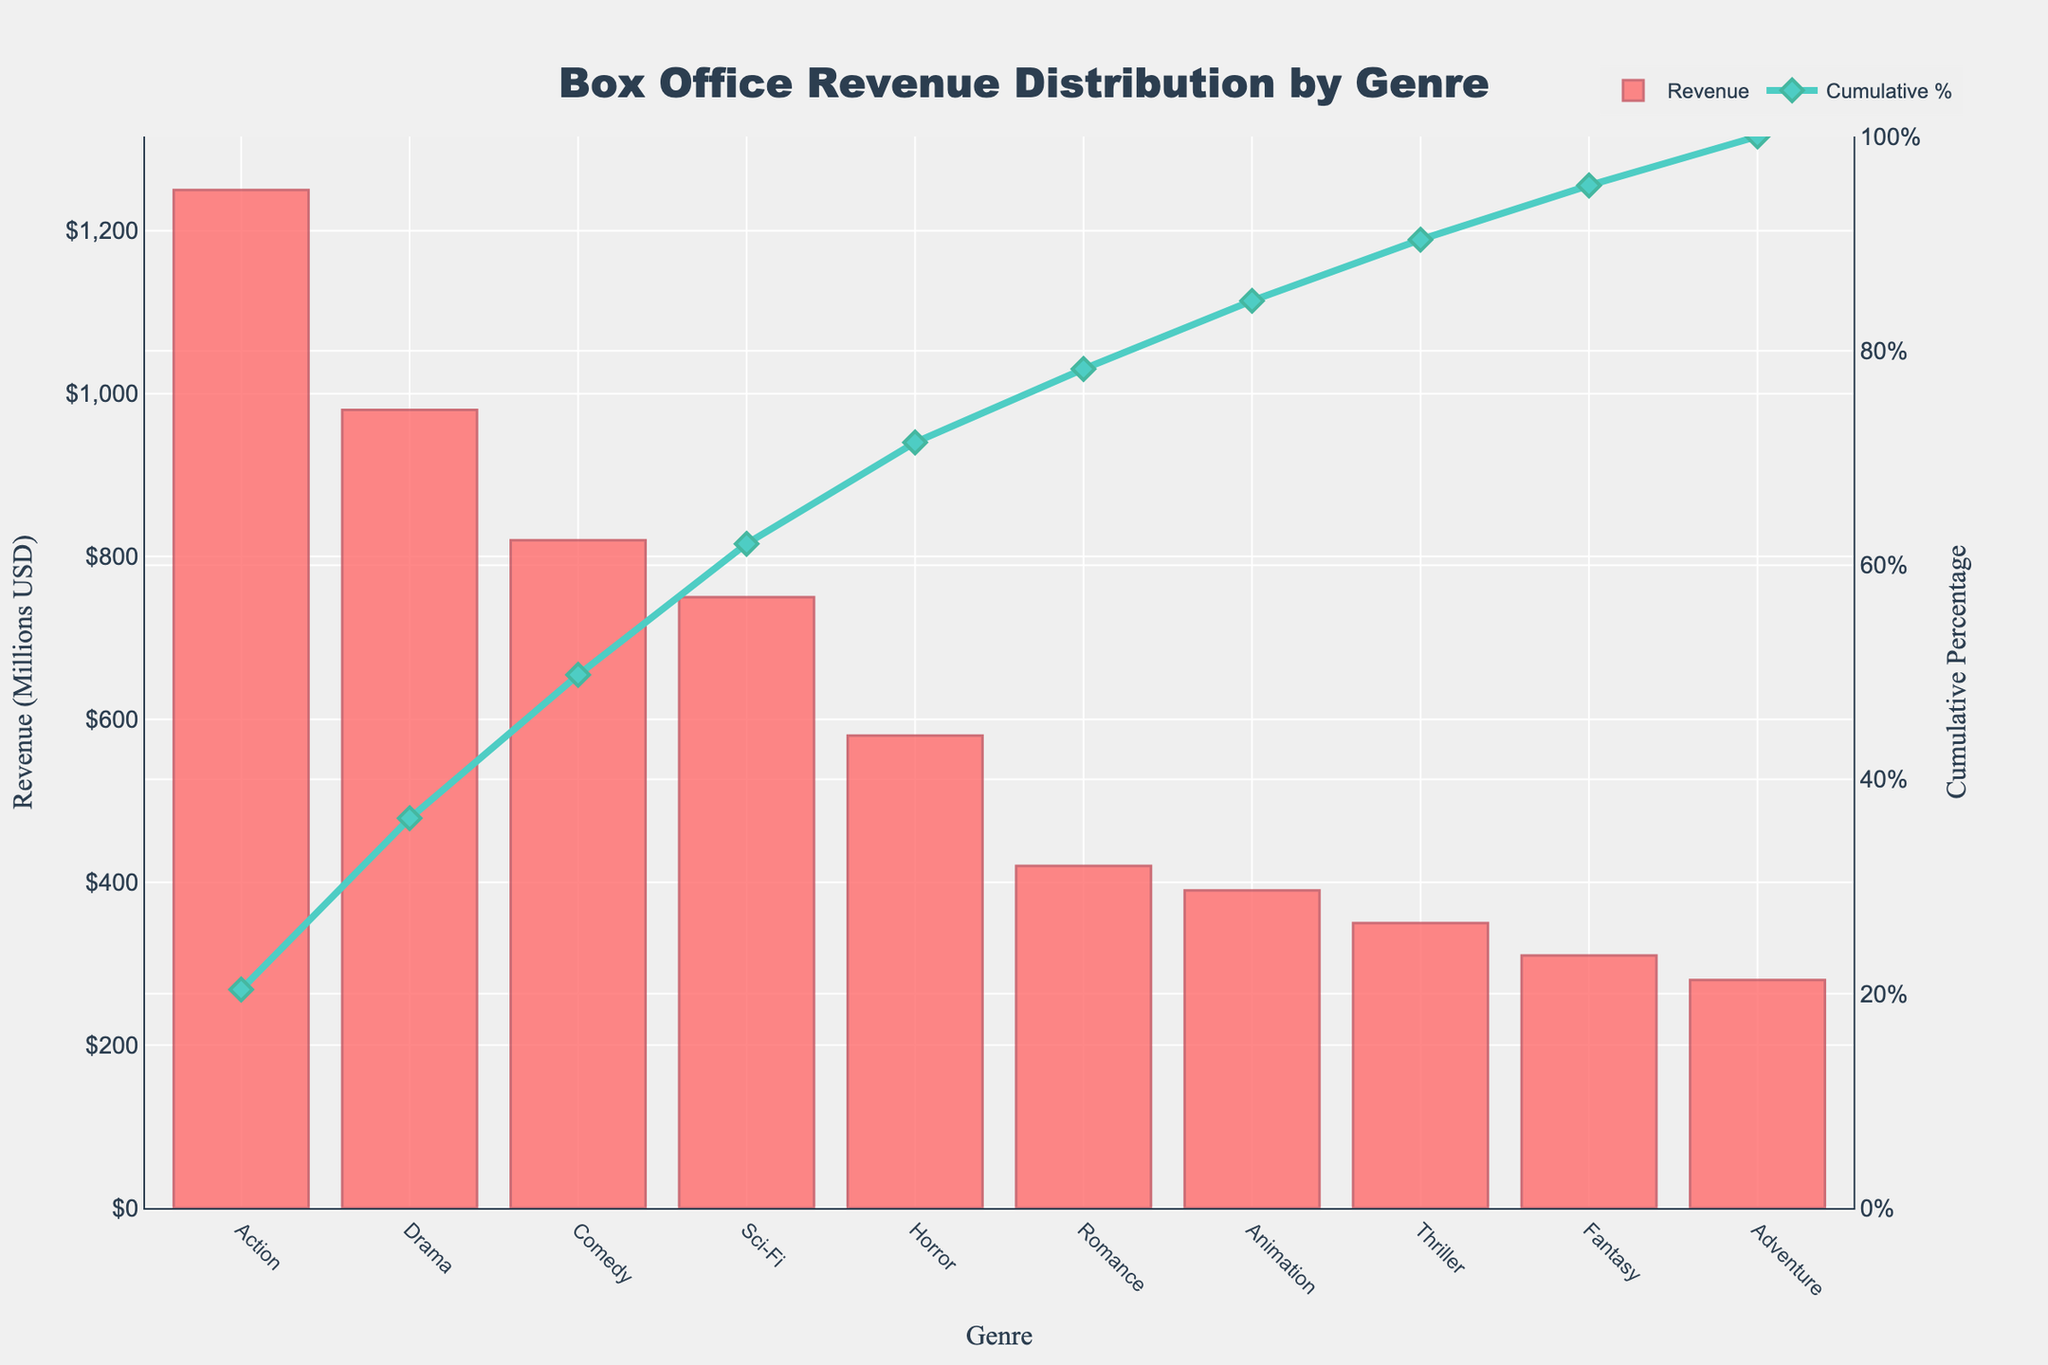Which genre brought in the highest box office revenue? The genre that brought in the highest box office revenue is the one with the tallest bar in the bar chart.
Answer: Action What's the cumulative percentage of box office revenue for the top three genres? To find the cumulative percentage for the top three genres, add up their revenue values and divide by the total revenue, then multiply by 100. Action, Drama, and Comedy have revenues of 1250, 980, and 820 million USD. ((1250+980+820) / (1250+980+820+750+580+420+390+350+310+280)) * 100 = (3050 / 6130) * 100.
Answer: 49.76% How much more revenue did Action generate compared to Comedy? Subtract the revenue of Comedy from the revenue of Action. 1250 - 820 = 430 million USD.
Answer: 430 million USD Which genre has the lowest cumulative percentage, and what is it? The genre with the lowest cumulative percentage is the one with the smallest incremental increase on the cumulative percentage line. Adventure has the last point on the cumulative percentage line, so it has 100%.
Answer: Adventure, 100% What is the revenue for the genre with the fifth highest box office revenue? The fifth highest revenue can be determined by looking at the fifth tallest bar. The fifth genre is Horror, which generated 580 million USD.
Answer: 580 million USD Which genre marks the point beyond which the cumulative percentage exceeds 50%? Look at the cumulative percentage line to find where it first surpasses 50%; this point will indicate the genre. After adding up Action, Drama, and Comedy, which total about 50%; Sci-Fi will push it just above.
Answer: Sci-Fi What are the total earnings of genres that made less than 500 million USD each? Identify genres with revenue less than 500 million USD: Romance, Animation, Thriller, Fantasy, and Adventure. Sum their revenues: 420 + 390 + 350 + 310 + 280 = 1750 million USD.
Answer: 1750 million USD How does the cumulative percentage change from Horror to Romance? Note the cumulative percentages at Horror and Romance and subtract the former from the latter. Horror ends at 61.4%, and Romance starts at 68.3%, so the change is 68.3% - 61.4%.
Answer: 6.9% What percentage of the revenue did Animation contribute to the total box office? Divide the revenue for Animation by the total revenue and multiply by 100. (390 / 6130) * 100 = 6.36%.
Answer: 6.36% Which genres together constitute the bottom 30% of the box office revenue? To find this, look for genres after which the cumulative percentage reaches 70%. The cumulative percentage reaches 70% after Romance. So, the genres Romance, Animation, Thriller, Fantasy, and Adventure collectively make up the bottom 30%.
Answer: Romance, Animation, Thriller, Fantasy, and Adventure 